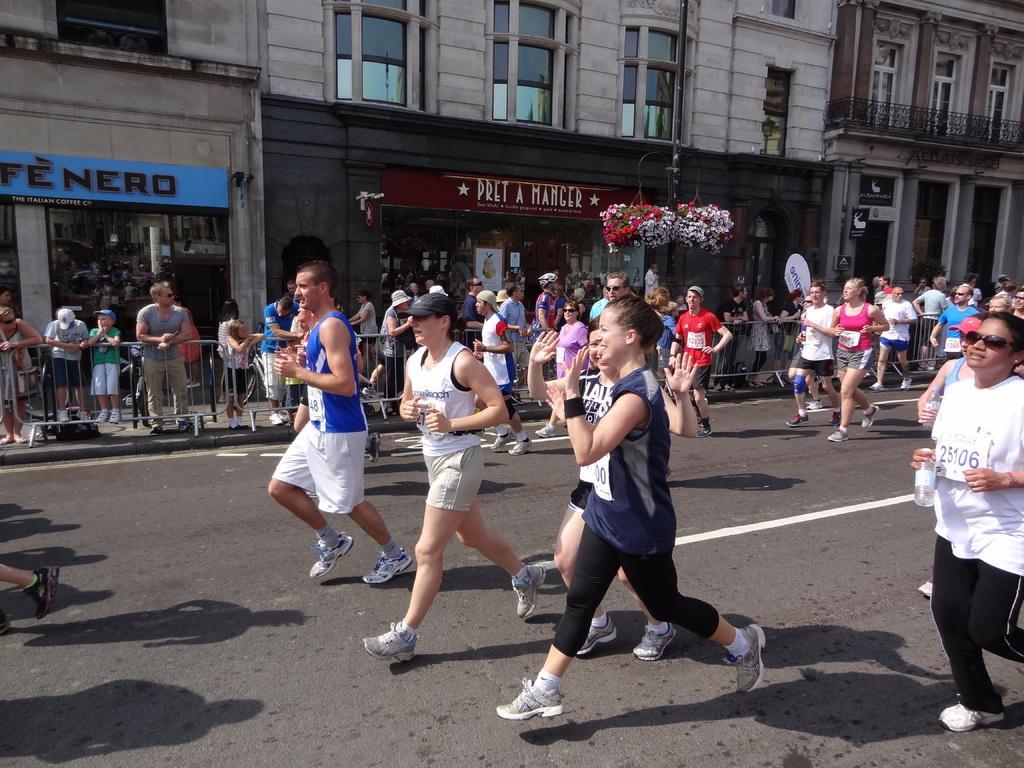Describe this image in one or two sentences. In this image we can see few people running on the road. Lady on the right side is wearing goggles and holding a bottle. In the back there are many people standing. There are railings. Also there are buildings with windows. And there are name boards. Also we can see flowers. 